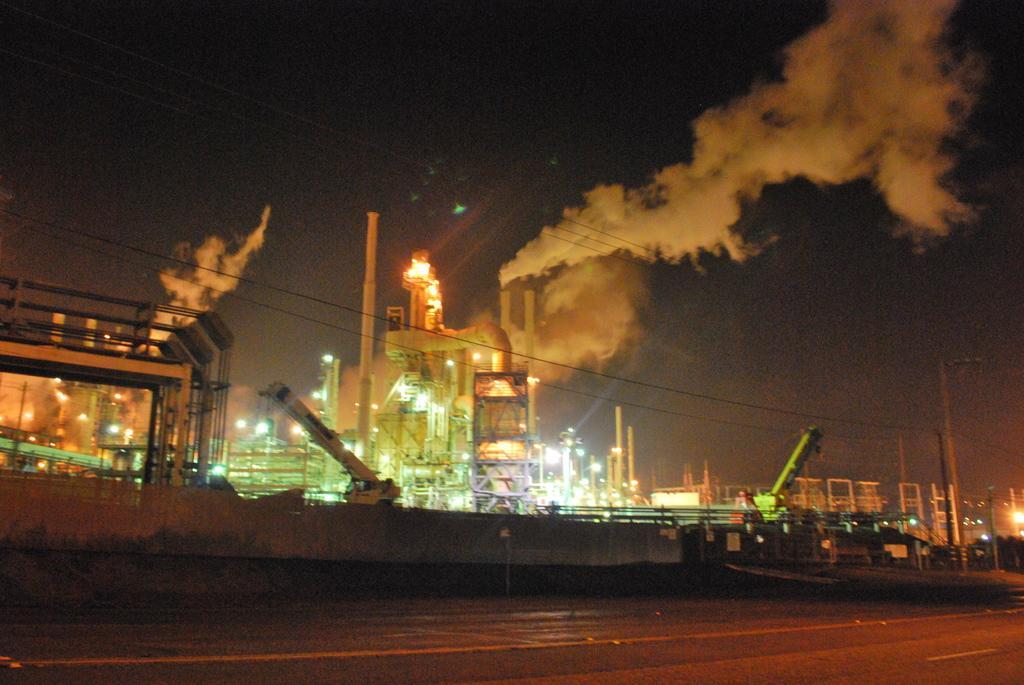In one or two sentences, can you explain what this image depicts? In this image in front there is a road. In the background of the image there are cranes, factories, poles and sky. 